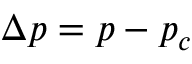<formula> <loc_0><loc_0><loc_500><loc_500>\Delta p = p - p _ { c }</formula> 